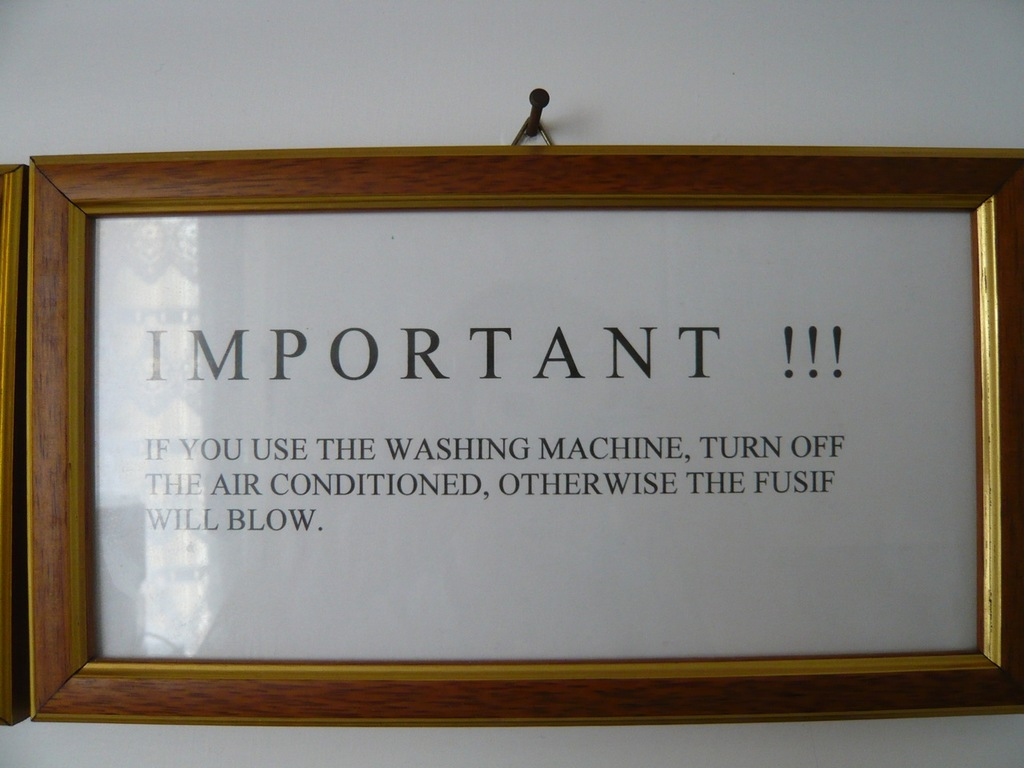Can you elaborate on why using both a washing machine and air conditioning at the same time might cause a fuse to blow? Using both a washing machine and air conditioning simultaneously can draw a high electrical current, exceeding the circuit's capacity. This excess demand can overheat the electrical wiring or components, causing the circuit breaker to trip or a fuse to blow to prevent electrical fires or appliance damage. It's a safety mechanism in electrical systems to avoid overloading. 